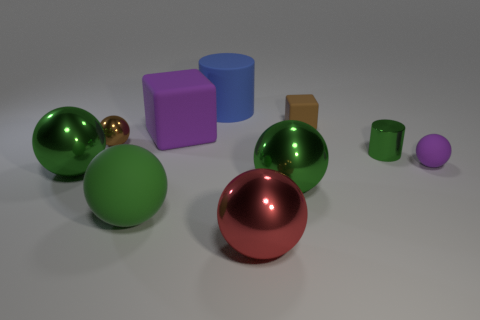What material is the big red sphere?
Give a very brief answer. Metal. There is a big rubber cylinder left of the tiny purple matte sphere; does it have the same color as the big cube?
Offer a terse response. No. Are there any other things that are the same shape as the large blue object?
Your answer should be very brief. Yes. There is another rubber object that is the same shape as the green rubber thing; what color is it?
Make the answer very short. Purple. What is the material of the small object to the right of the small cylinder?
Provide a short and direct response. Rubber. The big block has what color?
Your answer should be compact. Purple. There is a ball that is to the left of the brown shiny sphere; is it the same size as the small purple thing?
Give a very brief answer. No. What is the large red object in front of the purple rubber object to the left of the small object that is on the right side of the tiny green object made of?
Offer a terse response. Metal. Does the large metal thing to the left of the large red thing have the same color as the tiny ball that is behind the tiny purple ball?
Offer a terse response. No. What is the green thing behind the green shiny thing that is left of the green matte thing made of?
Your answer should be compact. Metal. 